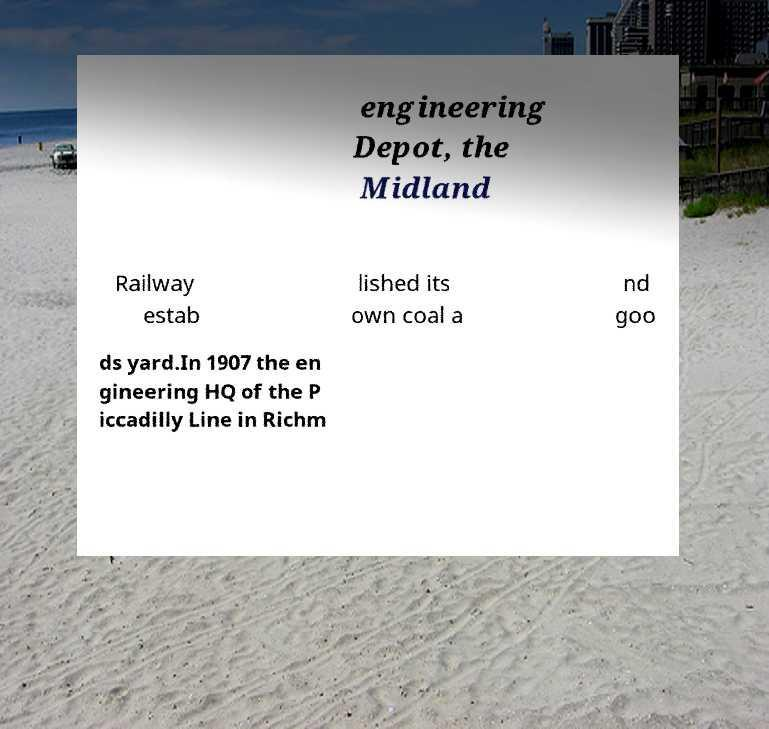For documentation purposes, I need the text within this image transcribed. Could you provide that? engineering Depot, the Midland Railway estab lished its own coal a nd goo ds yard.In 1907 the en gineering HQ of the P iccadilly Line in Richm 